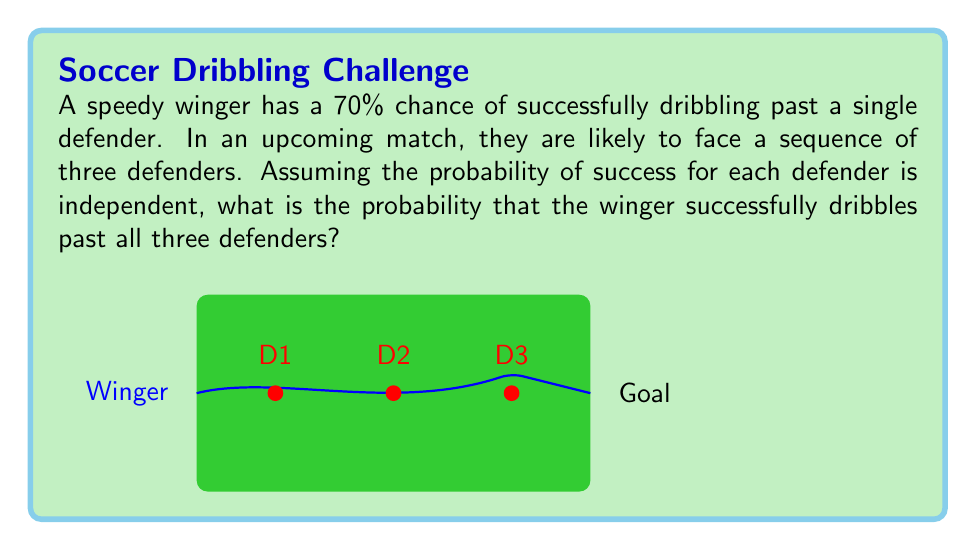Can you answer this question? To solve this problem, we need to apply the concept of independent events and probability multiplication.

Step 1: Identify the probability of success for a single defender.
P(success for one defender) = 0.70 or 70%

Step 2: Recognize that we need the winger to succeed against all three defenders independently.

Step 3: Apply the multiplication rule of probability for independent events.
For independent events A, B, and C:
P(A and B and C) = P(A) × P(B) × P(C)

In our case:
P(success against all three) = P(success against D1) × P(success against D2) × P(success against D3)

Step 4: Substitute the probabilities and calculate.
P(success against all three) = 0.70 × 0.70 × 0.70

Step 5: Compute the final probability.
P(success against all three) = 0.70³ = 0.343 or 34.3%

Therefore, the probability that the winger successfully dribbles past all three defenders is approximately 0.343 or 34.3%.
Answer: 0.343 or 34.3% 